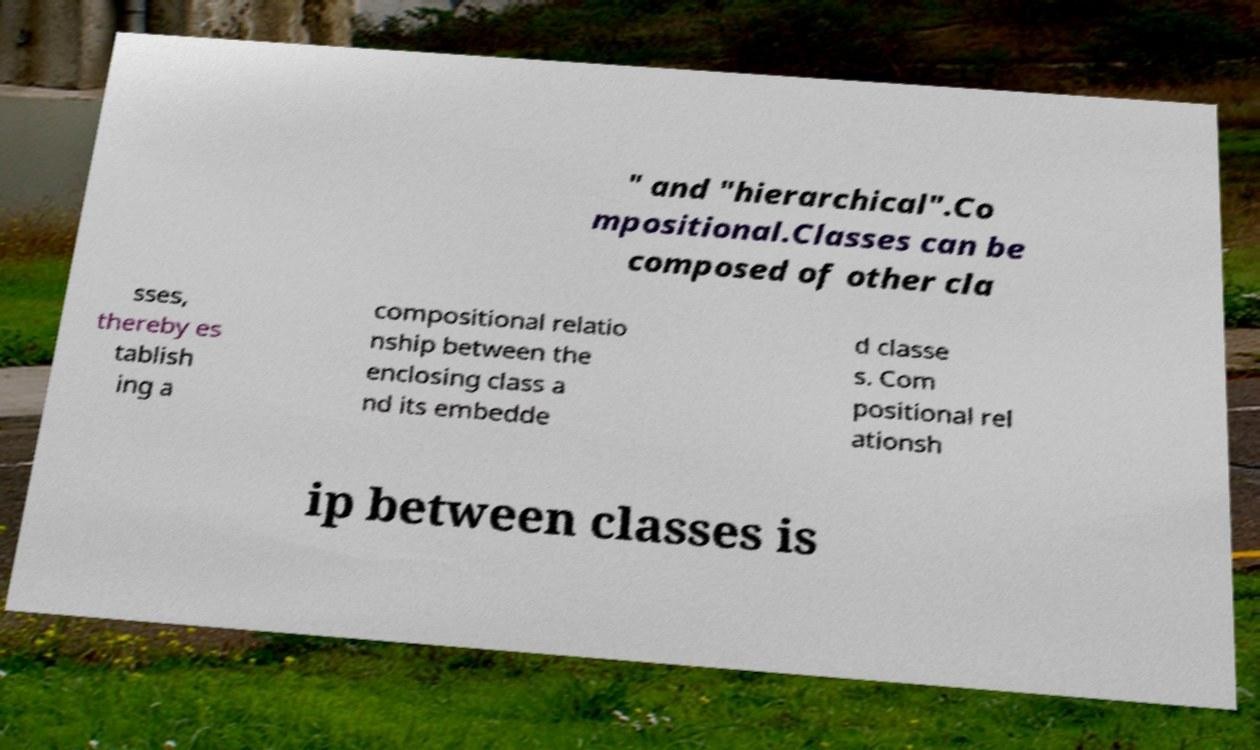What messages or text are displayed in this image? I need them in a readable, typed format. " and "hierarchical".Co mpositional.Classes can be composed of other cla sses, thereby es tablish ing a compositional relatio nship between the enclosing class a nd its embedde d classe s. Com positional rel ationsh ip between classes is 